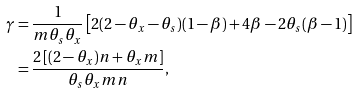Convert formula to latex. <formula><loc_0><loc_0><loc_500><loc_500>\gamma & = \frac { 1 } { m \theta _ { s } \theta _ { x } } \left [ 2 ( 2 - \theta _ { x } - \theta _ { s } ) ( 1 - \beta ) + 4 \beta - 2 \theta _ { s } ( \beta - 1 ) \right ] \\ & = \frac { 2 \left [ ( 2 - \theta _ { x } ) n + \theta _ { x } m \right ] } { \theta _ { s } \theta _ { x } m n } ,</formula> 